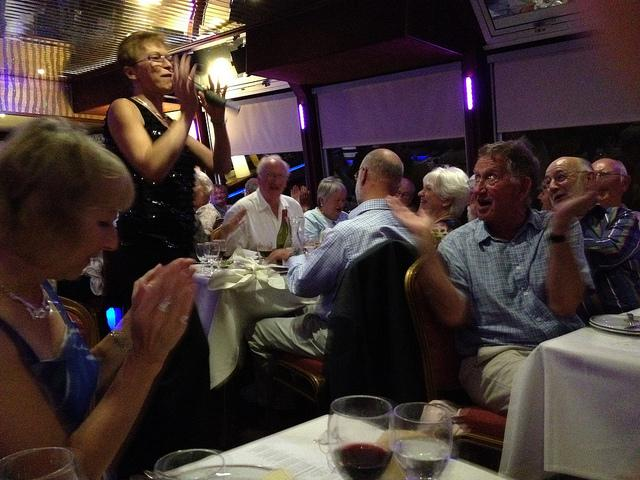What is the entertainment tonight for the people eating dinner? Please explain your reasoning. live singing. The lady is holding a microphone and performing for them. 